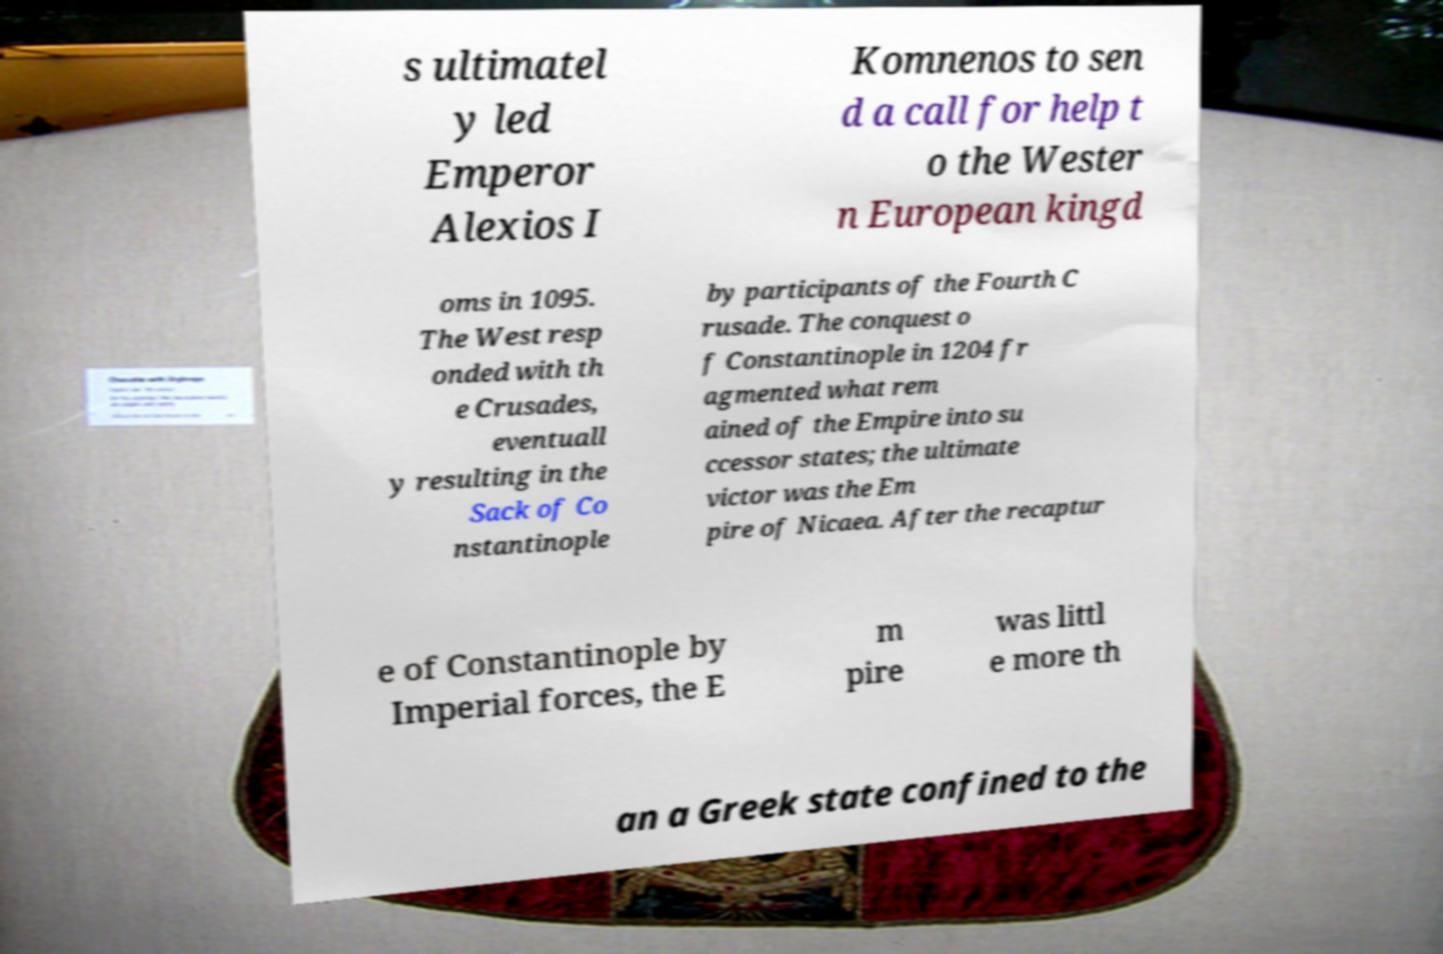Could you assist in decoding the text presented in this image and type it out clearly? s ultimatel y led Emperor Alexios I Komnenos to sen d a call for help t o the Wester n European kingd oms in 1095. The West resp onded with th e Crusades, eventuall y resulting in the Sack of Co nstantinople by participants of the Fourth C rusade. The conquest o f Constantinople in 1204 fr agmented what rem ained of the Empire into su ccessor states; the ultimate victor was the Em pire of Nicaea. After the recaptur e of Constantinople by Imperial forces, the E m pire was littl e more th an a Greek state confined to the 